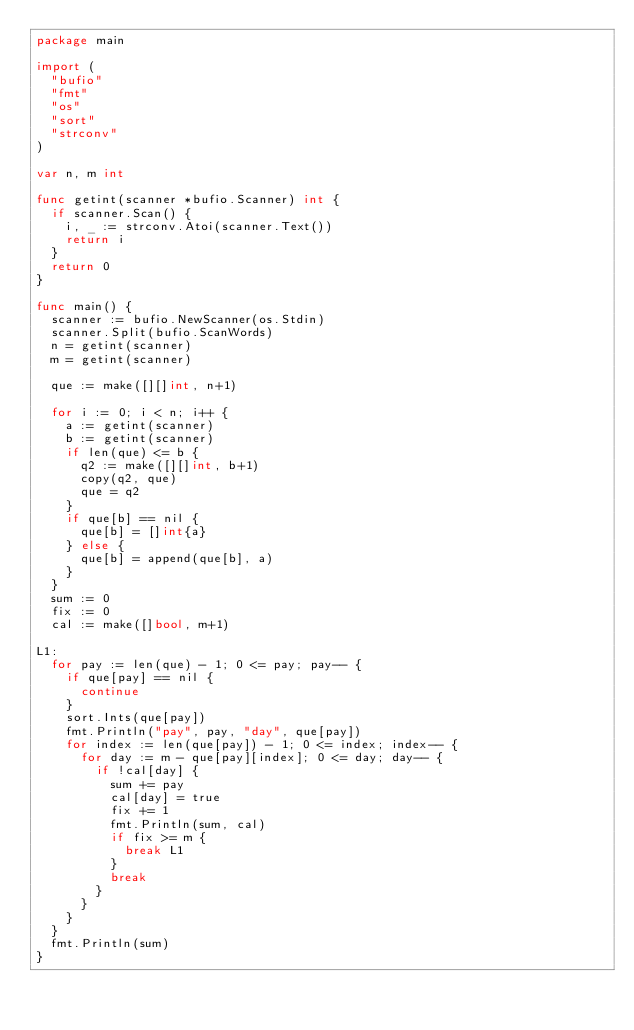<code> <loc_0><loc_0><loc_500><loc_500><_Go_>package main

import (
	"bufio"
	"fmt"
	"os"
	"sort"
	"strconv"
)

var n, m int

func getint(scanner *bufio.Scanner) int {
	if scanner.Scan() {
		i, _ := strconv.Atoi(scanner.Text())
		return i
	}
	return 0
}

func main() {
	scanner := bufio.NewScanner(os.Stdin)
	scanner.Split(bufio.ScanWords)
	n = getint(scanner)
	m = getint(scanner)

	que := make([][]int, n+1)

	for i := 0; i < n; i++ {
		a := getint(scanner)
		b := getint(scanner)
		if len(que) <= b {
			q2 := make([][]int, b+1)
			copy(q2, que)
			que = q2
		}
		if que[b] == nil {
			que[b] = []int{a}
		} else {
			que[b] = append(que[b], a)
		}
	}
	sum := 0
	fix := 0
	cal := make([]bool, m+1)

L1:
	for pay := len(que) - 1; 0 <= pay; pay-- {
		if que[pay] == nil {
			continue
		}
		sort.Ints(que[pay])
		fmt.Println("pay", pay, "day", que[pay])
		for index := len(que[pay]) - 1; 0 <= index; index-- {
			for day := m - que[pay][index]; 0 <= day; day-- {
				if !cal[day] {
					sum += pay
					cal[day] = true
					fix += 1
					fmt.Println(sum, cal)
					if fix >= m {
						break L1
					}
					break
				}
			}
		}
	}
	fmt.Println(sum)
}
</code> 